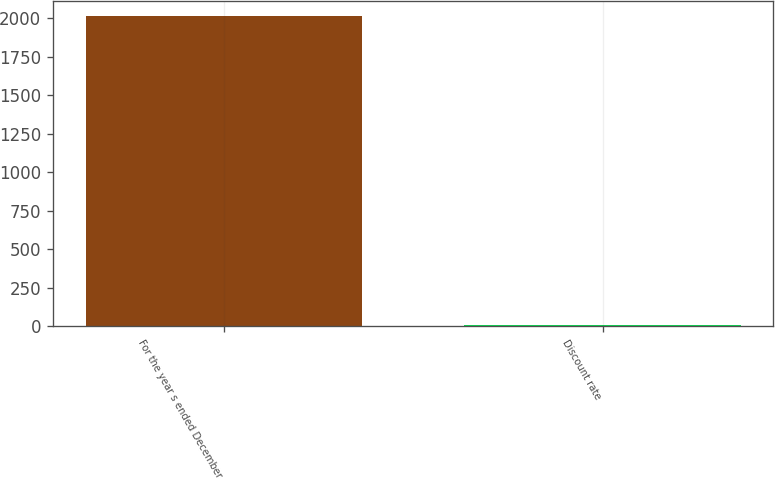Convert chart to OTSL. <chart><loc_0><loc_0><loc_500><loc_500><bar_chart><fcel>For the year s ended December<fcel>Discount rate<nl><fcel>2012<fcel>4.5<nl></chart> 